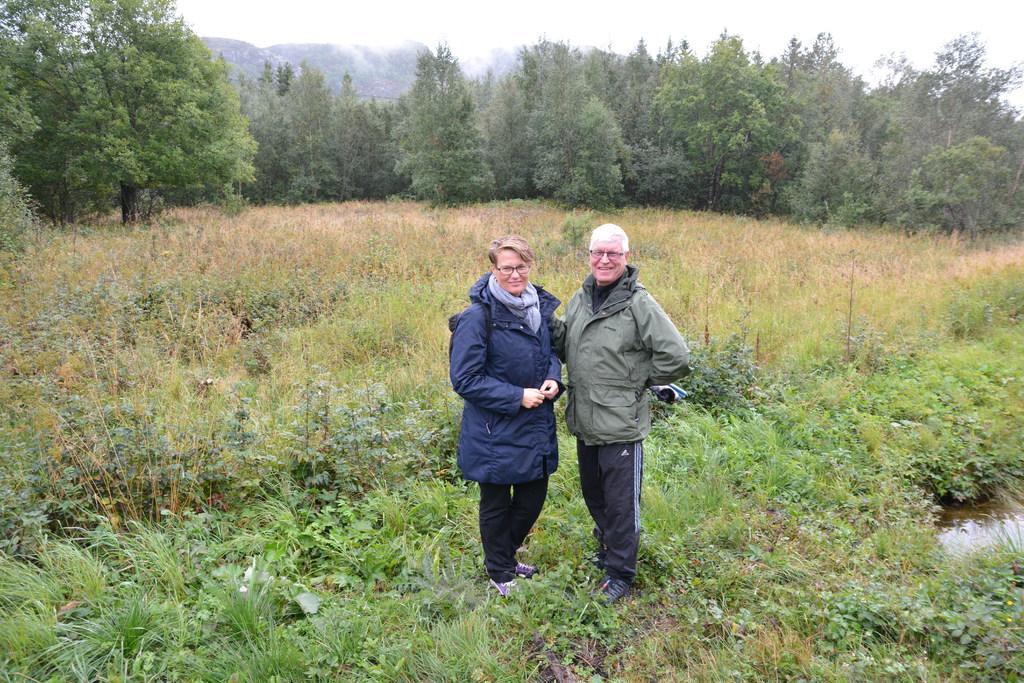Please provide a concise description of this image. In the image there is an old woman and man in jacket standing on grass land and plants with in the background and above its sky. 